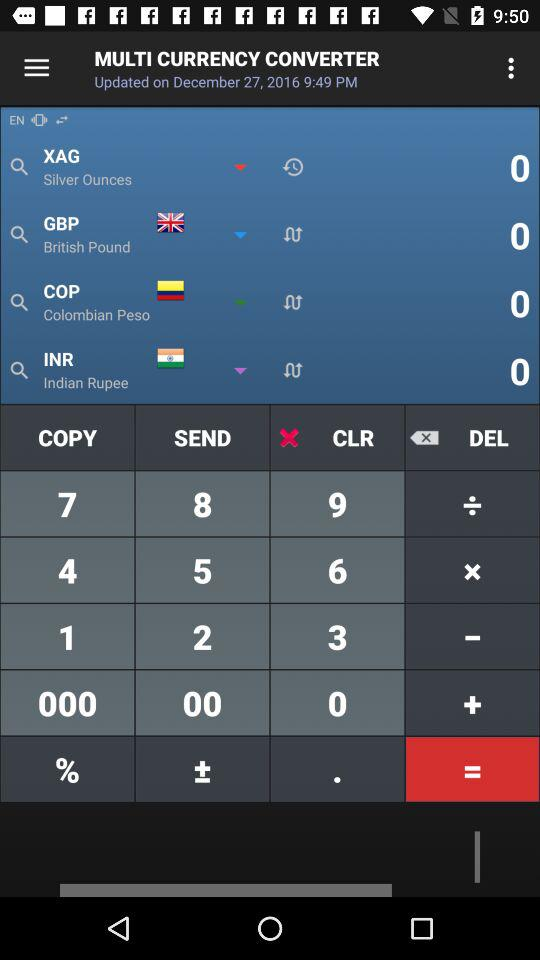At what time was the application last updated? The application was last updated at 9:49 PM. 